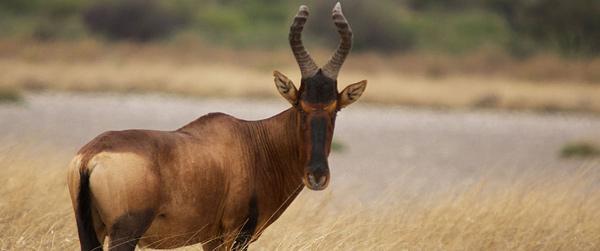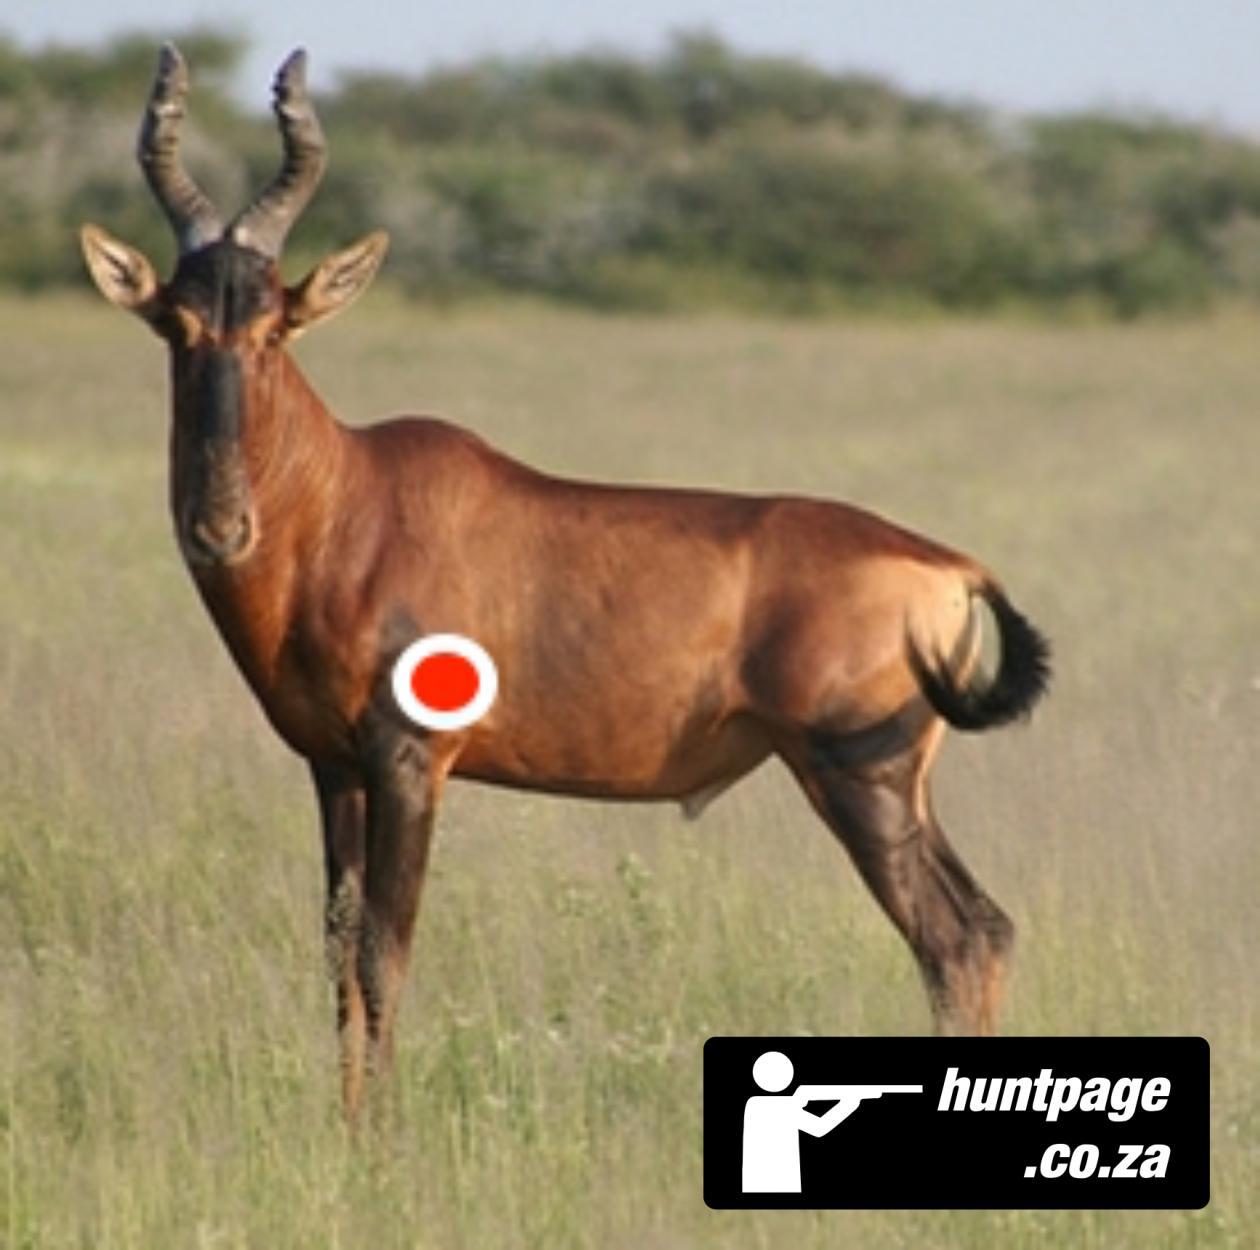The first image is the image on the left, the second image is the image on the right. Given the left and right images, does the statement "There are two buffalo in total." hold true? Answer yes or no. Yes. The first image is the image on the left, the second image is the image on the right. Evaluate the accuracy of this statement regarding the images: "One of the animals has a red circle on it.". Is it true? Answer yes or no. Yes. 